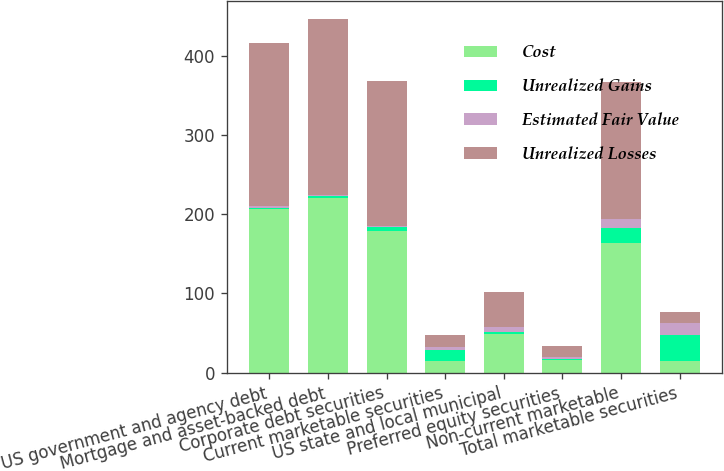Convert chart to OTSL. <chart><loc_0><loc_0><loc_500><loc_500><stacked_bar_chart><ecel><fcel>US government and agency debt<fcel>Mortgage and asset-backed debt<fcel>Corporate debt securities<fcel>Current marketable securities<fcel>US state and local municipal<fcel>Preferred equity securities<fcel>Non-current marketable<fcel>Total marketable securities<nl><fcel>Cost<fcel>207<fcel>220<fcel>179<fcel>14.5<fcel>49<fcel>16<fcel>164<fcel>14.5<nl><fcel>Unrealized Gains<fcel>1<fcel>3<fcel>5<fcel>14<fcel>2<fcel>1<fcel>19<fcel>33<nl><fcel>Estimated Fair Value<fcel>2<fcel>1<fcel>1<fcel>4<fcel>6<fcel>3<fcel>11<fcel>15<nl><fcel>Unrealized Losses<fcel>206<fcel>222<fcel>183<fcel>14.5<fcel>45<fcel>14<fcel>172<fcel>14.5<nl></chart> 